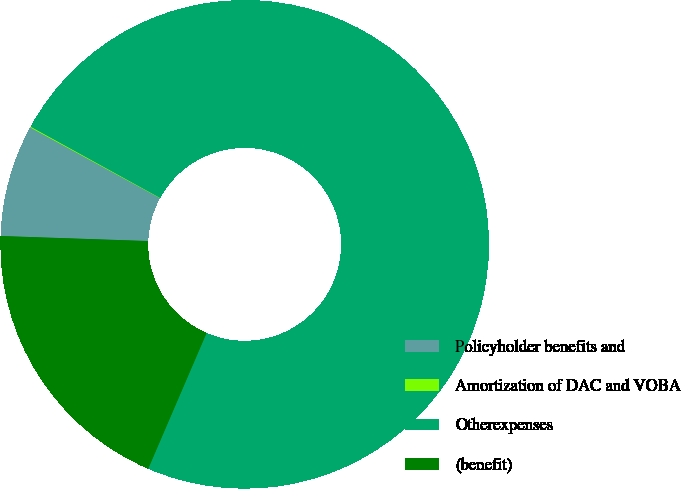<chart> <loc_0><loc_0><loc_500><loc_500><pie_chart><fcel>Policyholder benefits and<fcel>Amortization of DAC and VOBA<fcel>Otherexpenses<fcel>(benefit)<nl><fcel>7.4%<fcel>0.06%<fcel>73.45%<fcel>19.08%<nl></chart> 